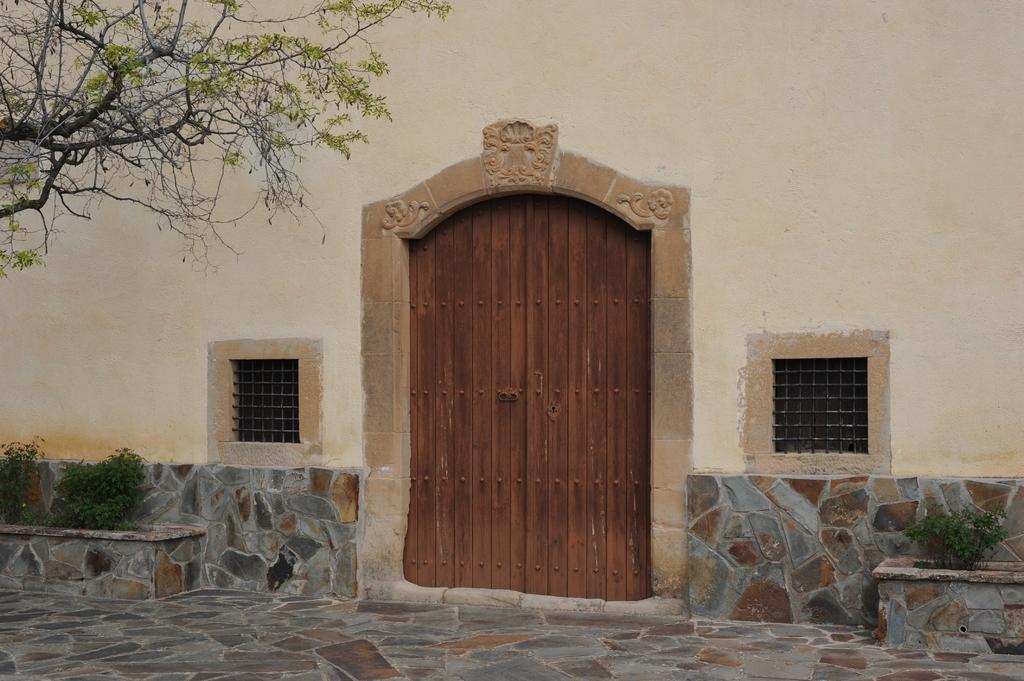In one or two sentences, can you explain what this image depicts? In this image in the center there is one building and door and two windows. At the bottom there is a floor and on the right side and left side there are some plants, on the left side there is one tree. 